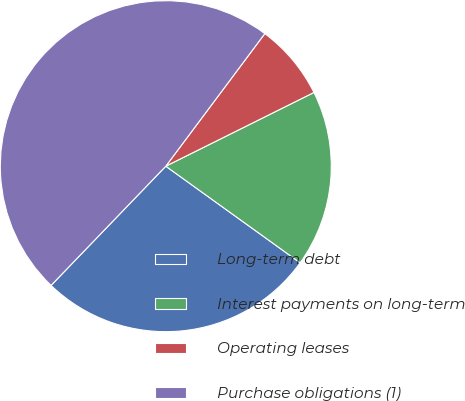Convert chart to OTSL. <chart><loc_0><loc_0><loc_500><loc_500><pie_chart><fcel>Long-term debt<fcel>Interest payments on long-term<fcel>Operating leases<fcel>Purchase obligations (1)<nl><fcel>27.27%<fcel>17.27%<fcel>7.44%<fcel>48.01%<nl></chart> 